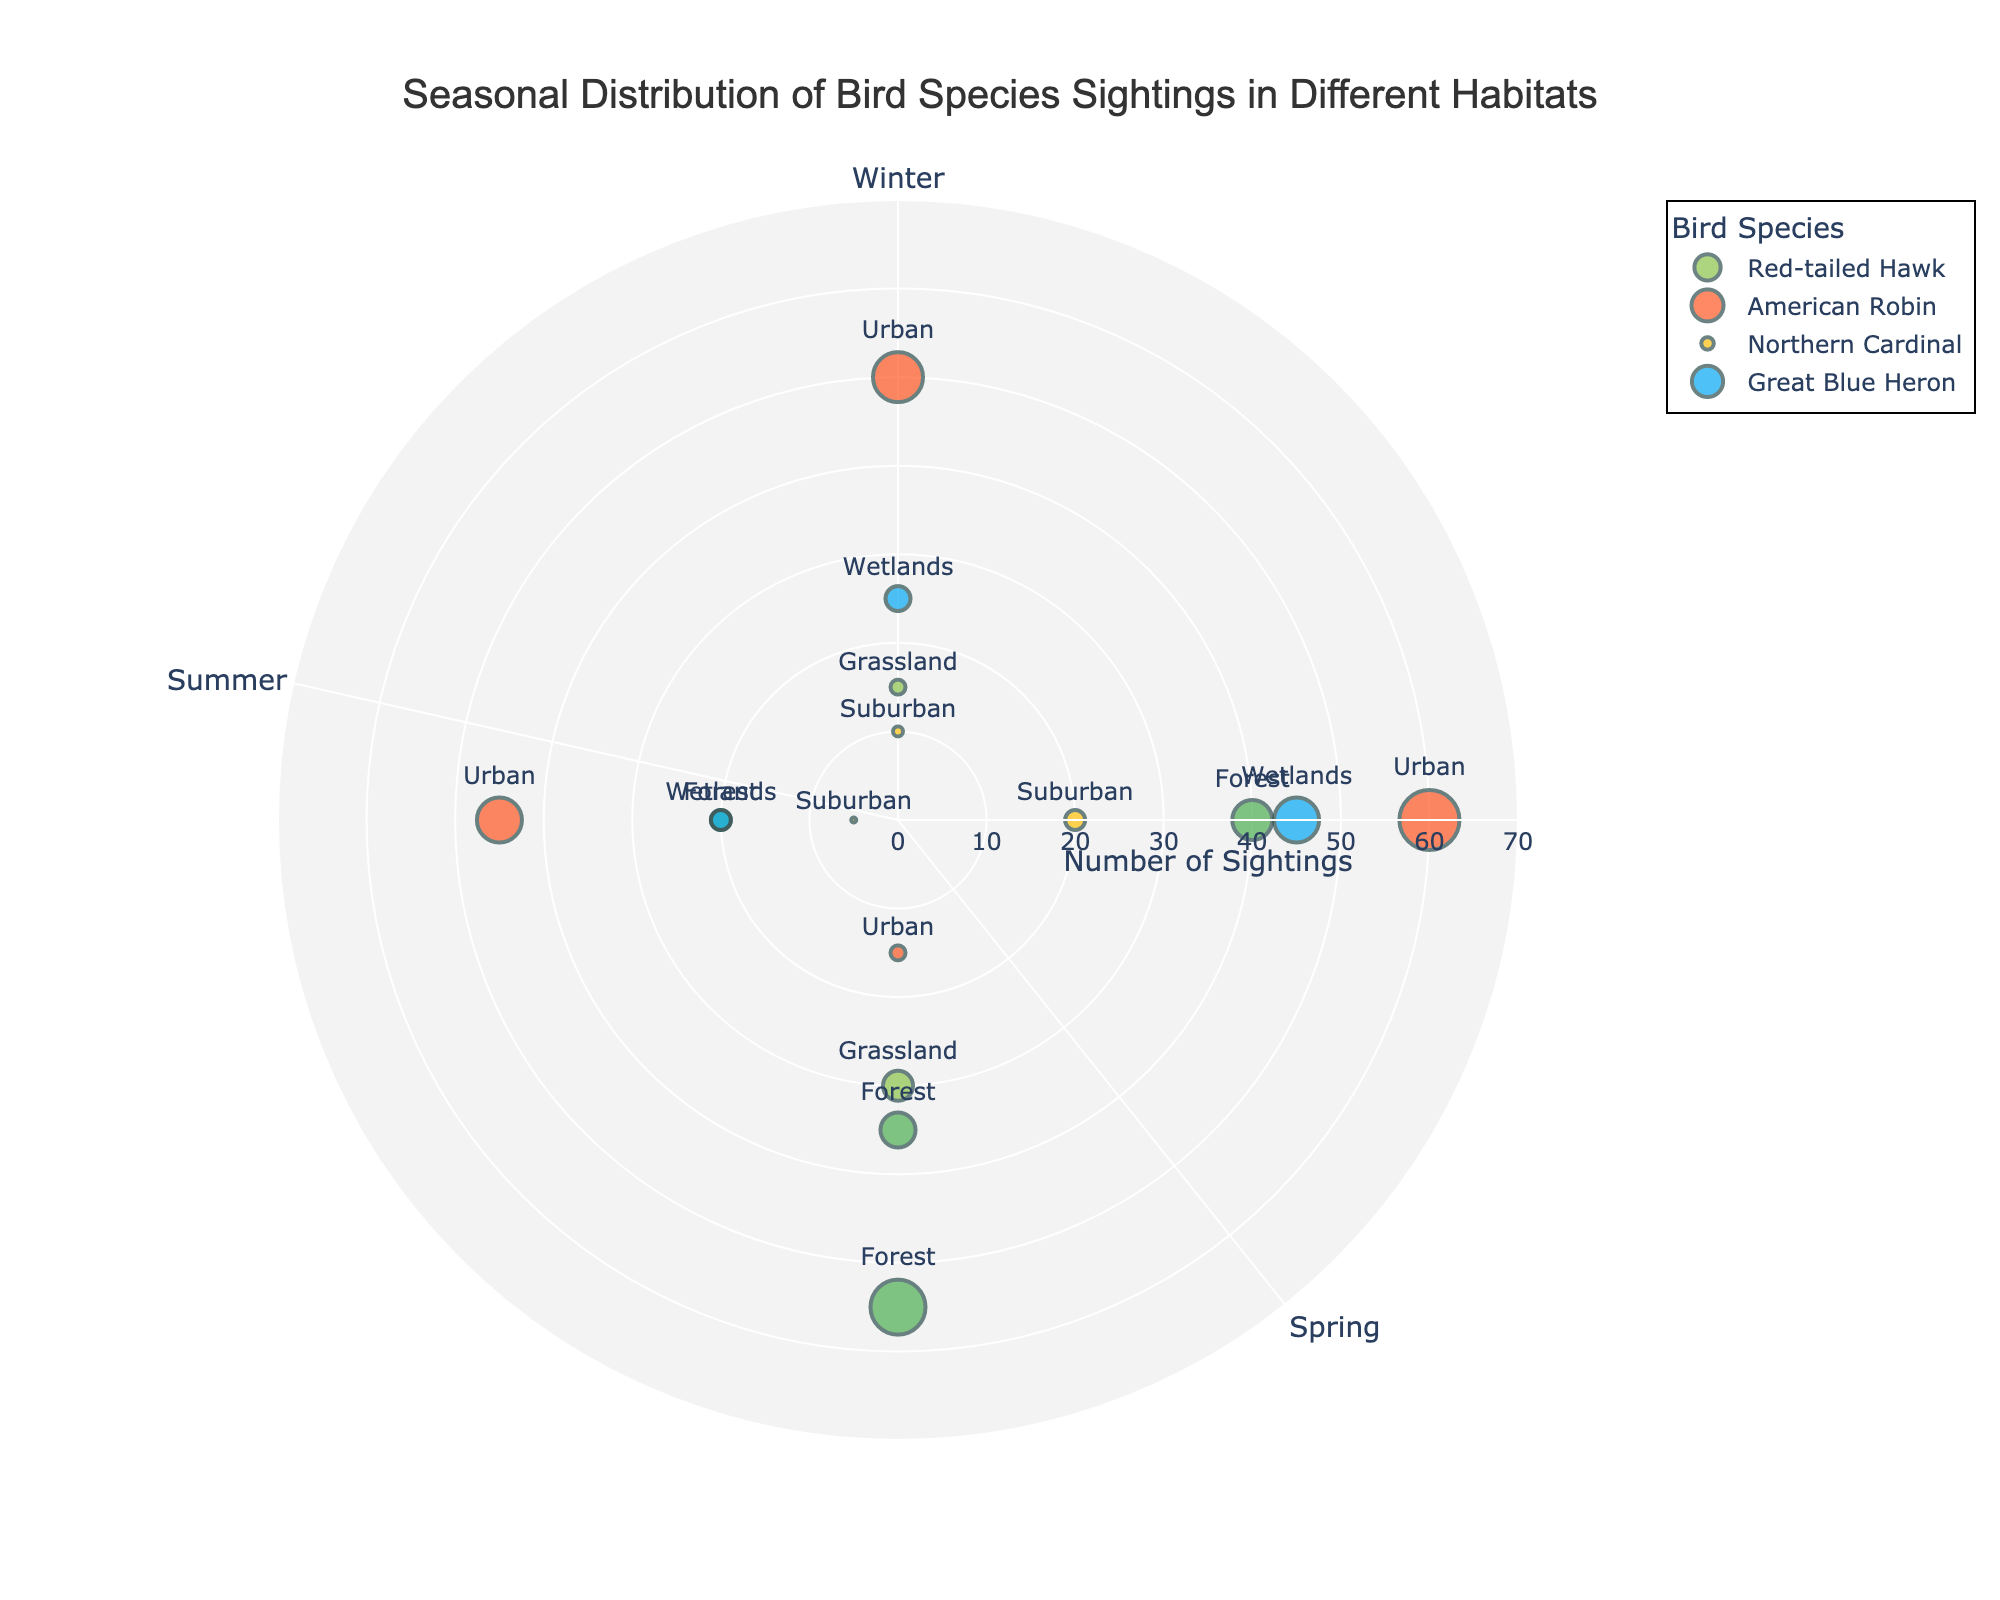What is the title of the figure? The title is usually positioned at the top of the figure. Here, the title is clearly marked in bold and readable text.
Answer: Seasonal Distribution of Bird Species Sightings in Different Habitats How many species are represented in the figure? By observing the legend of the figure, the various species names are listed, each with its corresponding markers.
Answer: 4 Which season has the most sightings for the American Robin? By following the radial lines starting from the center to the edge, we can see that the Spring (positioned at π/2 radians) has the maximum radius for American Robin.
Answer: Spring What color is used to represent the Suburban habitat? The color used for Suburban habitat can be identified in the markers and their legend representation in the figure.
Answer: Yellow How many sightings of Red-tailed Hawk were there in Summer? Look for the data point corresponding to Summer (π radians) and check the radius value indicated within or near the marker connected to Red-tailed Hawk.
Answer: 30 In which habitat was the Northern Cardinal observed during Fall, and how many sightings were there? Find the Northern Cardinal data points; specifically locate the one in the Fall position (3π/2 radians) and observe its annotation and radius.
Answer: Suburban, 5 In which habitat and season were the sightings for Great Blue Heron 45? Identify the Great Blue Heron markers; the sighting number 45 corresponds to a specific radial length and check its connected annotation in Spring (π/2 radians).
Answer: Wetlands, Spring Which species has sightings in both Forest and Urban habitats and in how many seasons each? Go through data markers for each species while noting the texts indicating habitats. Then count the respective seasons where each of these habitats appears.
Answer: American Robin; Forest - 1 season, Urban - 3 seasons How does the number of sightings of the Red-tailed Hawk compare between Spring and Winter? Examine the radius lengths of the Red-tailed Hawk markers for Spring (π/2 radians) and Winter (0 radians) and calculate the difference.
Answer: Spring has 25 more sightings than Winter 